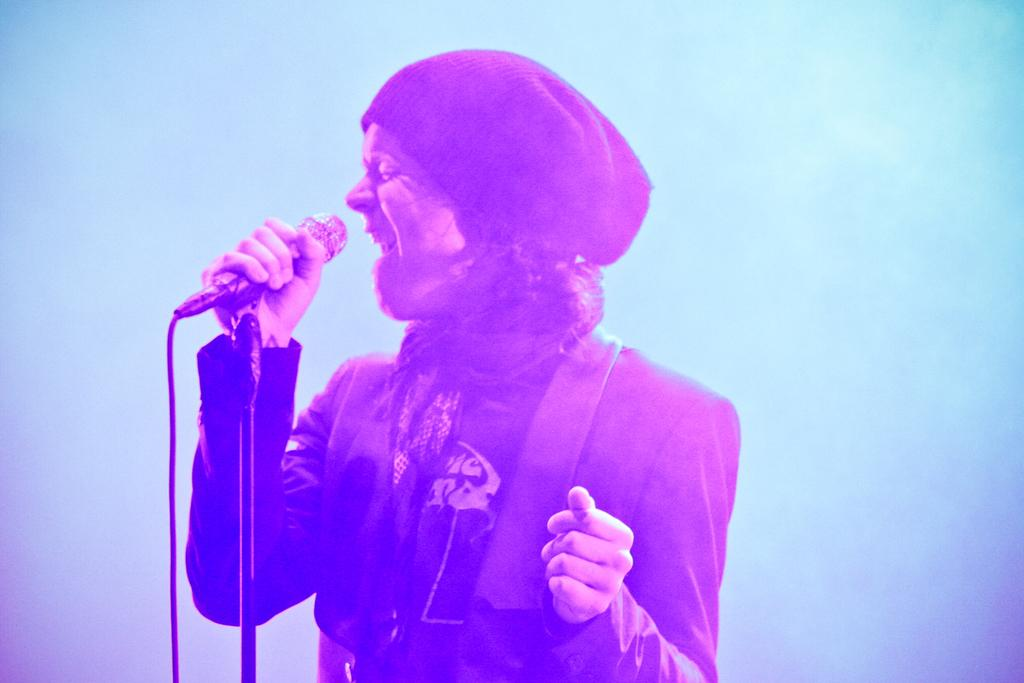Who is the main subject in the image? There is a person in the center of the image. What is the person doing in the image? The person is standing and appears to be singing. What object is the person holding in the image? The person is holding a microphone. What can be seen in the background of the image? There is fog in the background of the image. What type of apple is the person eating in the image? There is no apple present in the image; the person is holding a microphone and appears to be singing. Can you tell me where the person's grandmother lives based on the image? There is no information about the person's grandmother or her residence in the image. 